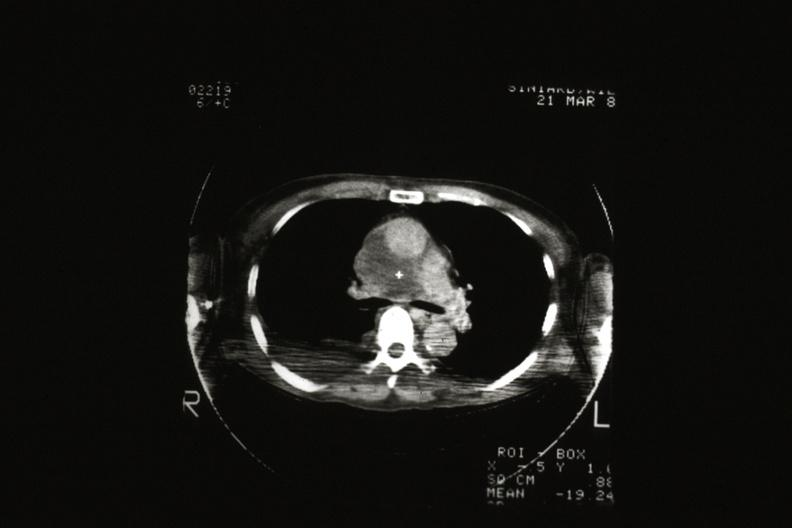s close-up of lesion present?
Answer the question using a single word or phrase. No 